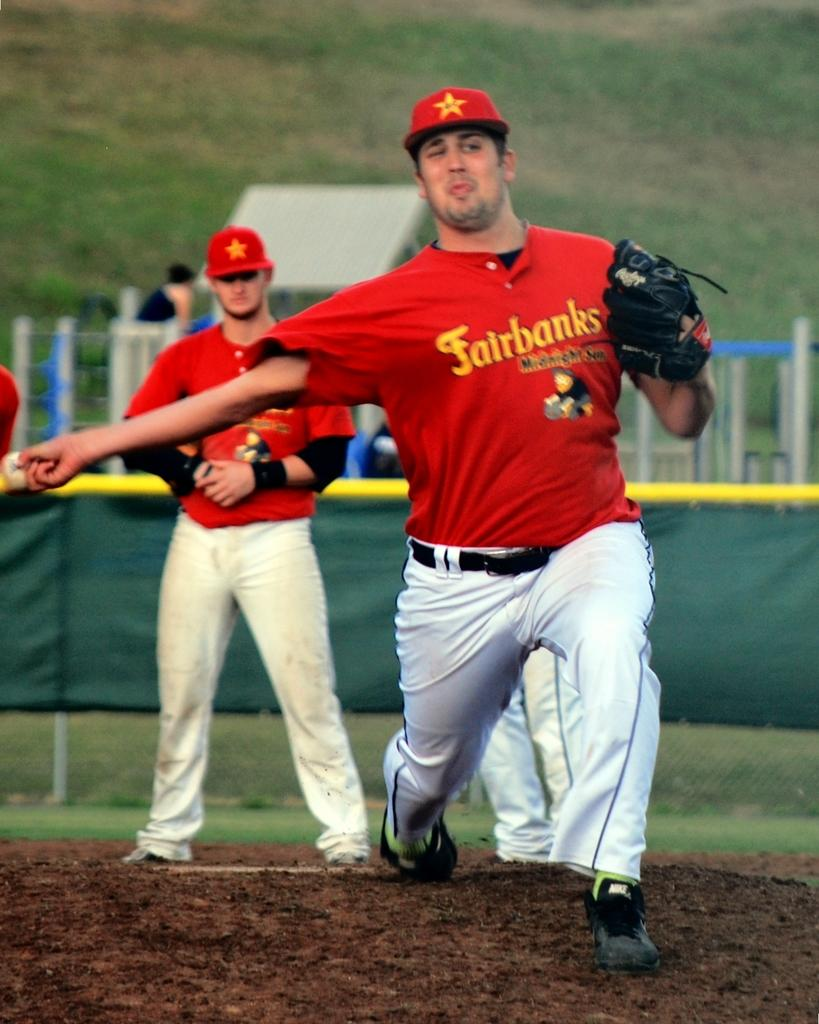Provide a one-sentence caption for the provided image. Two men playing what looks like baseball wearing red Fairbanks shirts. 